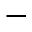Convert formula to latex. <formula><loc_0><loc_0><loc_500><loc_500>-</formula> 